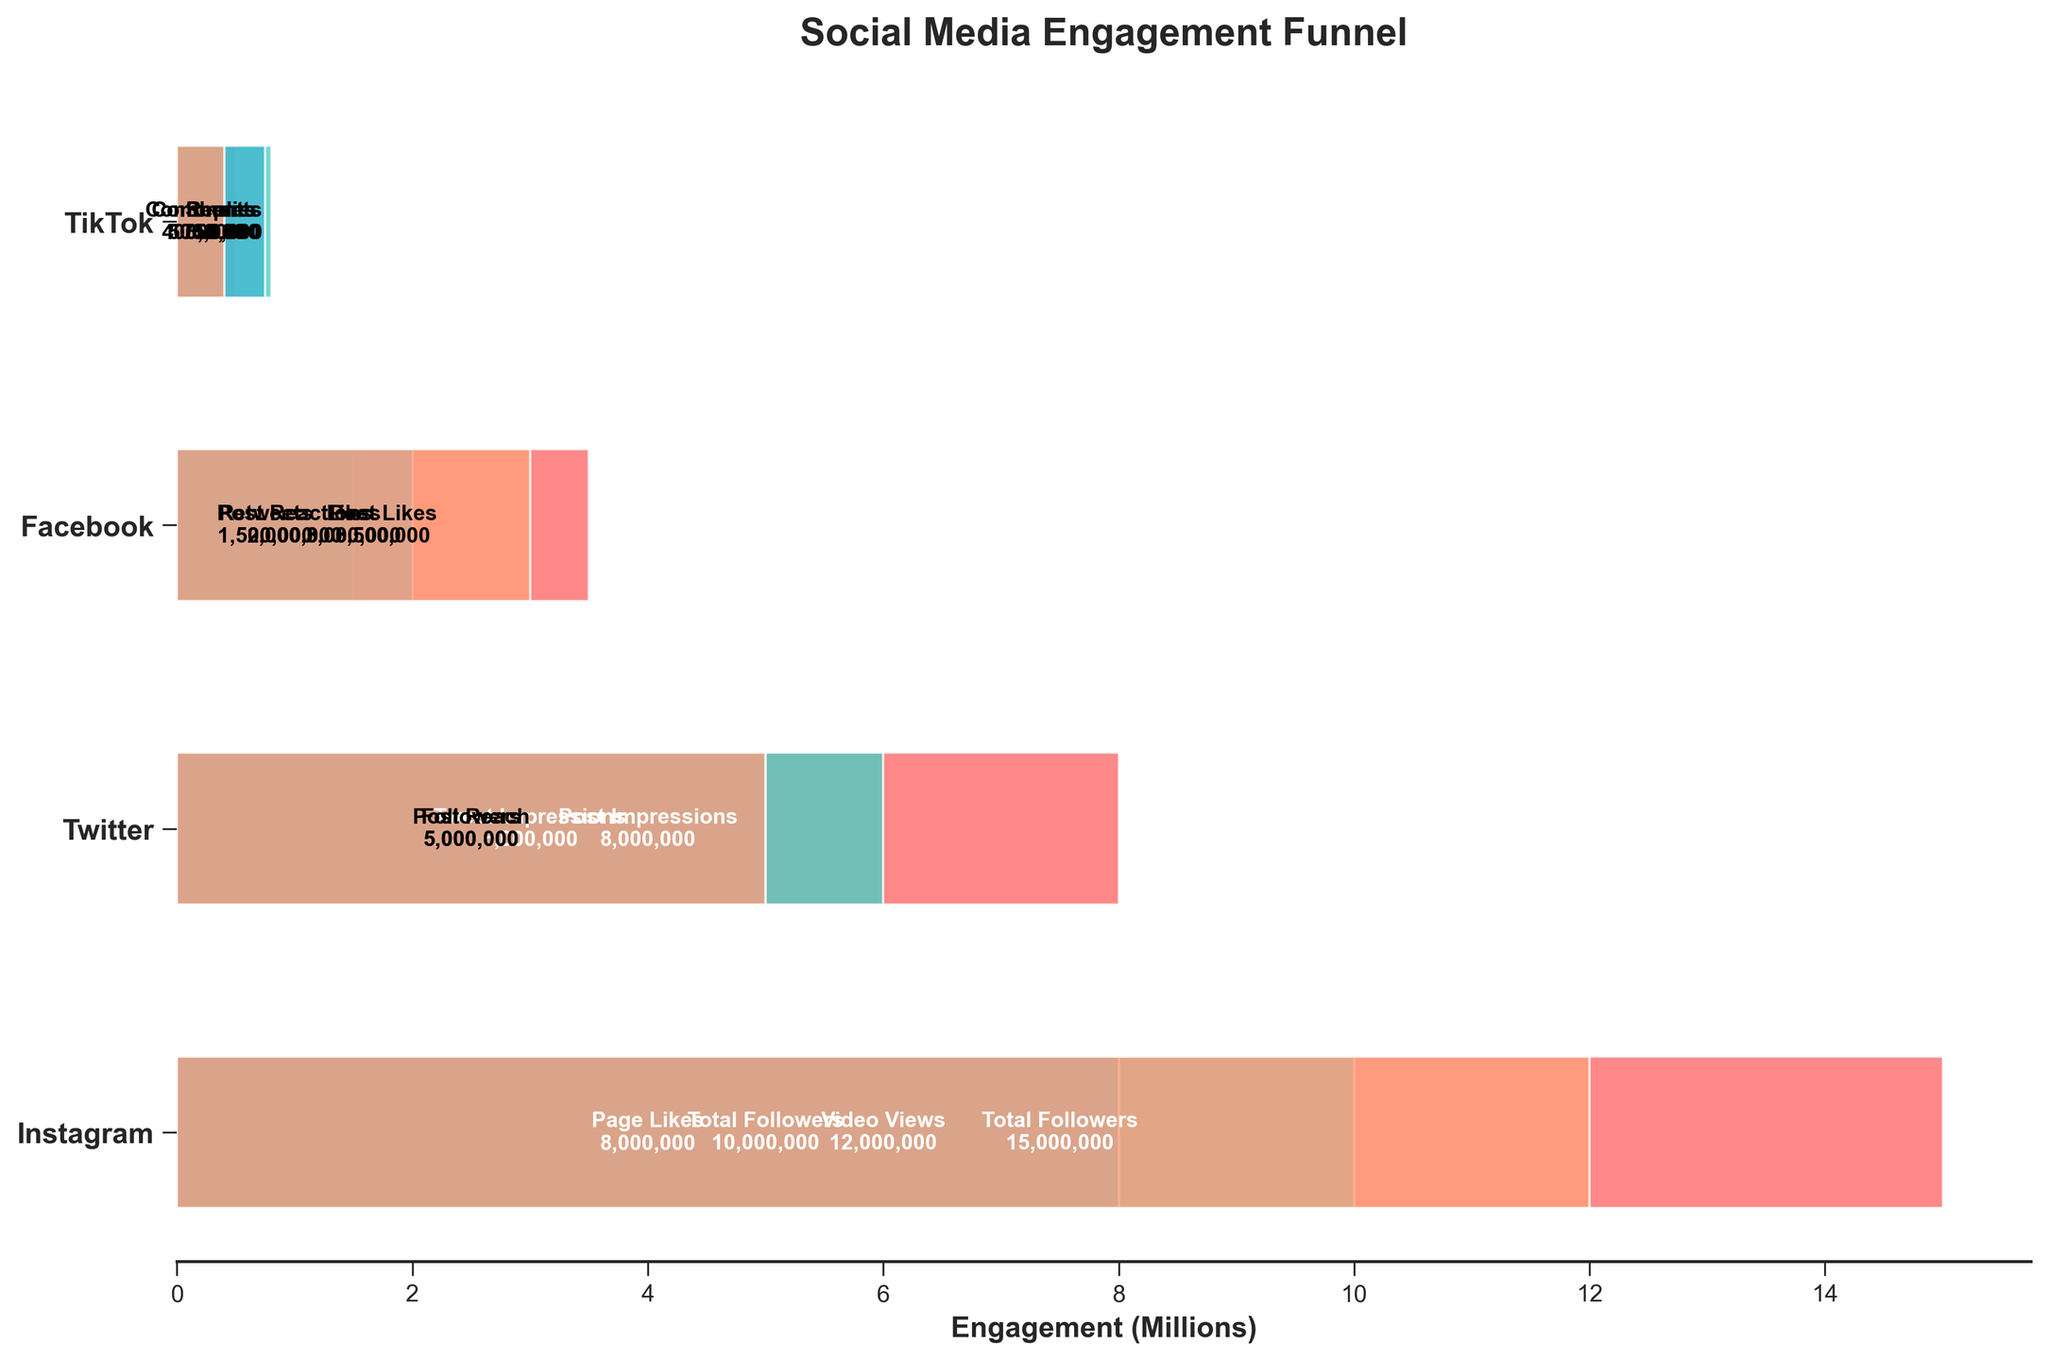What's the title of the figure? The title of the figure is usually located at the top of the chart. In this case, the title reads "Social Media Engagement Funnel".
Answer: Social Media Engagement Funnel Which platform has the highest total follower count? To determine which platform has the highest total follower count, we look at the first engagement metric for each platform and compare their values: Instagram has 15,000,000, Twitter has 10,000,000, Facebook has 8,000,000, and TikTok has 5,000,000. Thus, Instagram has the highest total follower count.
Answer: Instagram What is the difference between Instagram's total followers and post impressions? Instagram's total followers are 15,000,000, and the post impressions are 8,000,000. Subtracting post impressions from total followers gives us the difference: 15,000,000 - 8,000,000 = 7,000,000.
Answer: 7,000,000 How many comments did Instagram receive compared to TikTok? Instagram has 500,000 comments while TikTok has 400,000 comments. The difference is found by subtracting TikTok's comments from Instagram's: 500,000 - 400,000 = 100,000.
Answer: 100,000 Which platform has the largest discrepancy between impressions (or video views) and likes? To find the platform with the largest discrepancy, we compare the difference between impressions (or video views) and likes for each platform:
- Instagram: 8,000,000 - 3,500,000 = 4,500,000
- Twitter: 6,000,000 - 1,500,000 = 4,500,000
- Facebook: 5,000,000 - 2,000,000 = 3,000,000
- TikTok: 12,000,000 - 3,000,000 = 9,000,000
Hence, the platform with the largest discrepancy is TikTok.
Answer: TikTok Which platform received the fewest interactions in the form of shares or retweets? Looking at the engagement data for shares or retweets:
- Instagram: Data not available
- Twitter: 1,500,000 retweets
- Facebook: 750,000 shares
- TikTok: Data not available
Thus, Facebook received the fewest interactions in the form of shares.
Answer: Facebook Order the platforms by their total engagement count, starting from the highest. Calculate the sum of all engagement counts for each platform:
- Instagram: 15,000,000 + 8,000,000 + 3,500,000 + 500,000 = 27,000,000
- Twitter: 10,000,000 + 6,000,000 + 1,500,000 + 800,000 = 18,300,000
- Facebook: 8,000,000 + 5,000,000 + 2,000,000 + 750,000 = 15,750,000
- TikTok: 5,000,000 + 12,000,000 + 3,000,000 + 400,000 = 20,400,000
Rank them: Instagram > TikTok > Twitter > Facebook.
Answer: Instagram, TikTok, Twitter, Facebook What is the average number of comments received across all platforms? The total number of comments across all platforms is 500,000 (Instagram) + 800,000 (Twitter) + 0 (Facebook) + 400,000 (TikTok) = 1,700,000. There are 4 platforms. The average is 1,700,000 / 4 = 425,000.
Answer: 425,000 Which platform has a higher total count of engagement activities, Twitter or Facebook? Sum the engagement metrics for both platforms:
- Twitter: 10,000,000 (followers) + 6,000,000 (tweet impressions) + 1,500,000 (retweets) + 800,000 (replies) = 18,300,000
- Facebook: 8,000,000 (page likes) + 5,000,000 (post reach) + 2,000,000 (post reactions) + 750,000 (shares) = 15,750,000
Twitter has a higher total count of engagement activities.
Answer: Twitter 